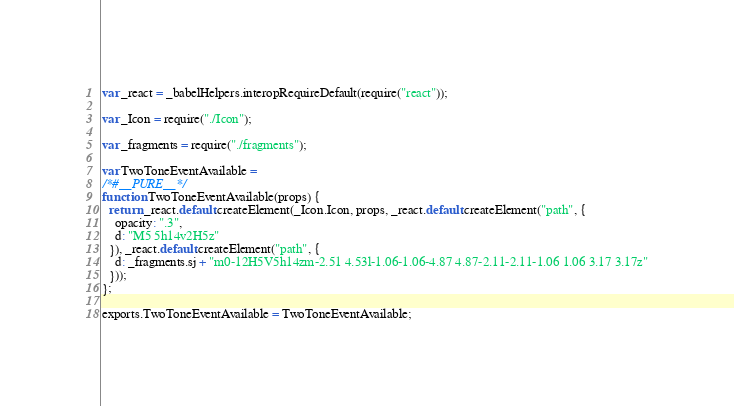Convert code to text. <code><loc_0><loc_0><loc_500><loc_500><_JavaScript_>var _react = _babelHelpers.interopRequireDefault(require("react"));

var _Icon = require("./Icon");

var _fragments = require("./fragments");

var TwoToneEventAvailable =
/*#__PURE__*/
function TwoToneEventAvailable(props) {
  return _react.default.createElement(_Icon.Icon, props, _react.default.createElement("path", {
    opacity: ".3",
    d: "M5 5h14v2H5z"
  }), _react.default.createElement("path", {
    d: _fragments.sj + "m0-12H5V5h14zm-2.51 4.53l-1.06-1.06-4.87 4.87-2.11-2.11-1.06 1.06 3.17 3.17z"
  }));
};

exports.TwoToneEventAvailable = TwoToneEventAvailable;</code> 